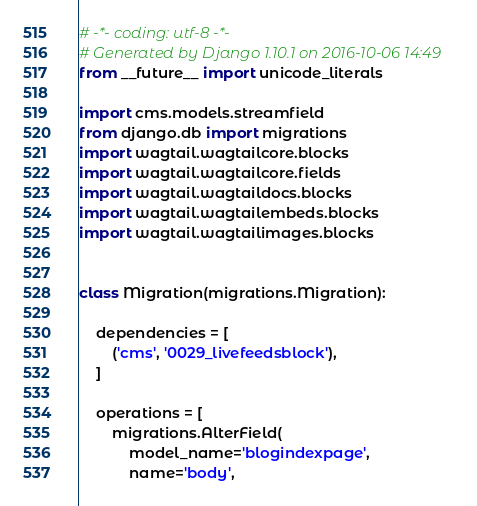Convert code to text. <code><loc_0><loc_0><loc_500><loc_500><_Python_># -*- coding: utf-8 -*-
# Generated by Django 1.10.1 on 2016-10-06 14:49
from __future__ import unicode_literals

import cms.models.streamfield
from django.db import migrations
import wagtail.wagtailcore.blocks
import wagtail.wagtailcore.fields
import wagtail.wagtaildocs.blocks
import wagtail.wagtailembeds.blocks
import wagtail.wagtailimages.blocks


class Migration(migrations.Migration):

    dependencies = [
        ('cms', '0029_livefeedsblock'),
    ]

    operations = [
        migrations.AlterField(
            model_name='blogindexpage',
            name='body',</code> 